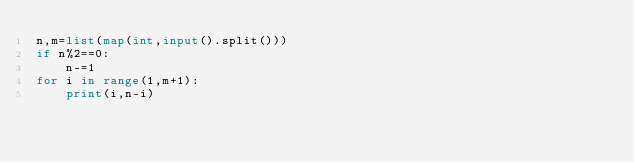Convert code to text. <code><loc_0><loc_0><loc_500><loc_500><_Python_>n,m=list(map(int,input().split()))
if n%2==0:
    n-=1
for i in range(1,m+1):
    print(i,n-i)
</code> 